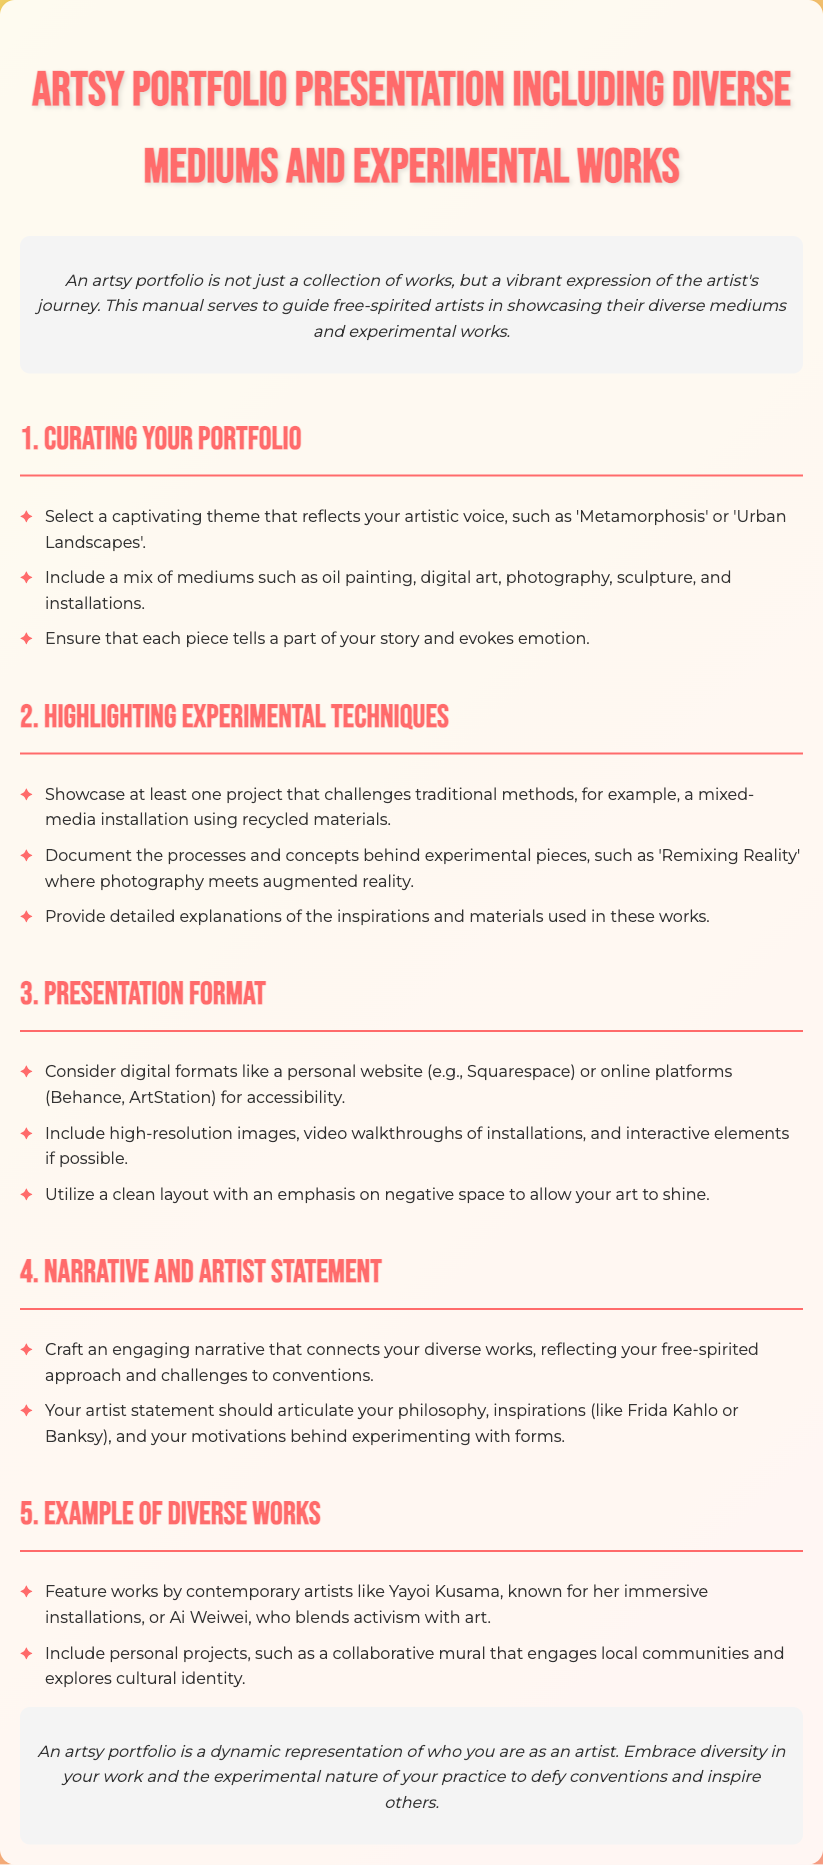what is the title of the manual? The title of the manual is prominently displayed at the top of the document, which is "Artsy Portfolio Presentation Including Diverse Mediums and Experimental Works".
Answer: Artsy Portfolio Presentation Including Diverse Mediums and Experimental Works how many sections are in the manual? The manual includes five distinct sections as outlined in the headings.
Answer: 5 name one contemporary artist mentioned in the document. The document provides examples of contemporary artists whose works can inspire portfolio presentations.
Answer: Yayoi Kusama what is a key theme suggested for curating a portfolio? The manual suggests selecting a captivating theme that reflects the artist's voice, with examples like 'Metamorphosis' or 'Urban Landscapes'.
Answer: Urban Landscapes what should be included in the artist statement? The artist statement should articulate the artist's philosophy, inspirations, and motivations behind their experimental works.
Answer: Philosophy, inspirations, motivations what type of project does the manual suggest for highlighting experimental techniques? The manual recommends showcasing at least one project that challenges traditional methods, specifically mentioning mixed-media installations using recycled materials.
Answer: Mixed-media installation using recycled materials which digital platforms are recommended for presentation? The manual indicates considering digital formats for portfolio presentation, mentioning specific platforms suited for this purpose.
Answer: Squarespace, Behance, ArtStation what is emphasized in the presentation format preferences? The document emphasizes utilizing a clean layout with an emphasis on negative space to enhance the visibility of the art.
Answer: Negative space 